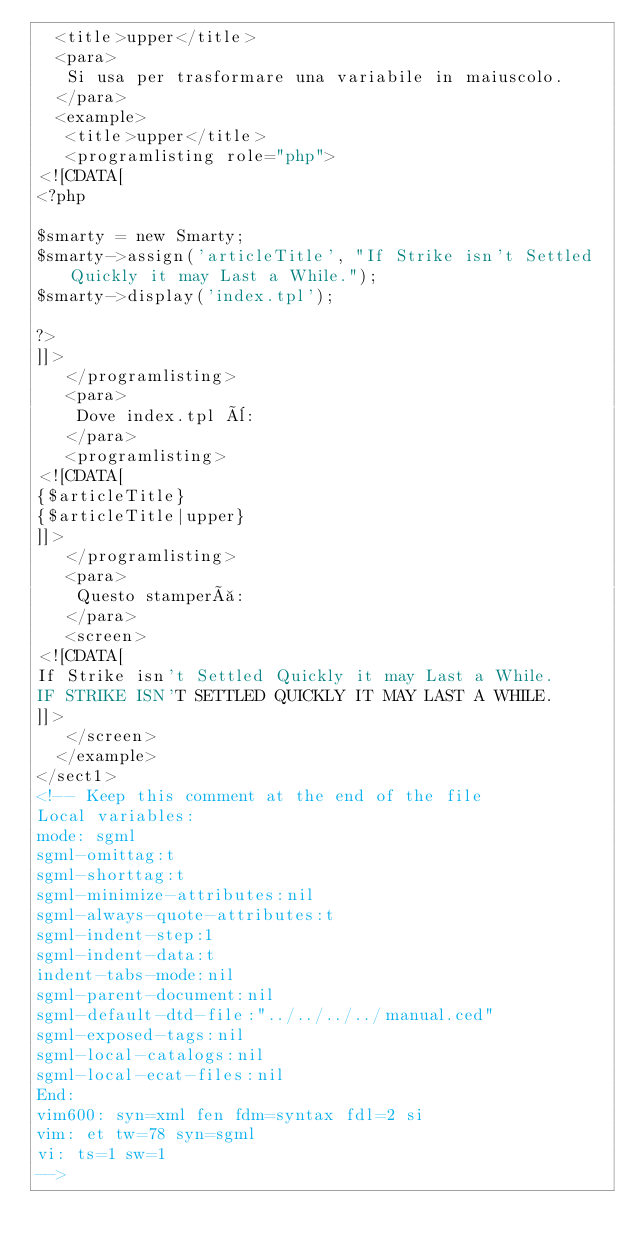Convert code to text. <code><loc_0><loc_0><loc_500><loc_500><_XML_>  <title>upper</title>
  <para>
   Si usa per trasformare una variabile in maiuscolo.
  </para>
  <example>
   <title>upper</title>
   <programlisting role="php">
<![CDATA[
<?php

$smarty = new Smarty;
$smarty->assign('articleTitle', "If Strike isn't Settled Quickly it may Last a While.");
$smarty->display('index.tpl');

?>
]]>
   </programlisting>
   <para>
    Dove index.tpl è:
   </para>
   <programlisting>
<![CDATA[
{$articleTitle}
{$articleTitle|upper}
]]>
   </programlisting>
   <para>
    Questo stamperà:
   </para>
   <screen>
<![CDATA[
If Strike isn't Settled Quickly it may Last a While.
IF STRIKE ISN'T SETTLED QUICKLY IT MAY LAST A WHILE.
]]>
   </screen>
  </example>
</sect1>
<!-- Keep this comment at the end of the file
Local variables:
mode: sgml
sgml-omittag:t
sgml-shorttag:t
sgml-minimize-attributes:nil
sgml-always-quote-attributes:t
sgml-indent-step:1
sgml-indent-data:t
indent-tabs-mode:nil
sgml-parent-document:nil
sgml-default-dtd-file:"../../../../manual.ced"
sgml-exposed-tags:nil
sgml-local-catalogs:nil
sgml-local-ecat-files:nil
End:
vim600: syn=xml fen fdm=syntax fdl=2 si
vim: et tw=78 syn=sgml
vi: ts=1 sw=1
-->
</code> 